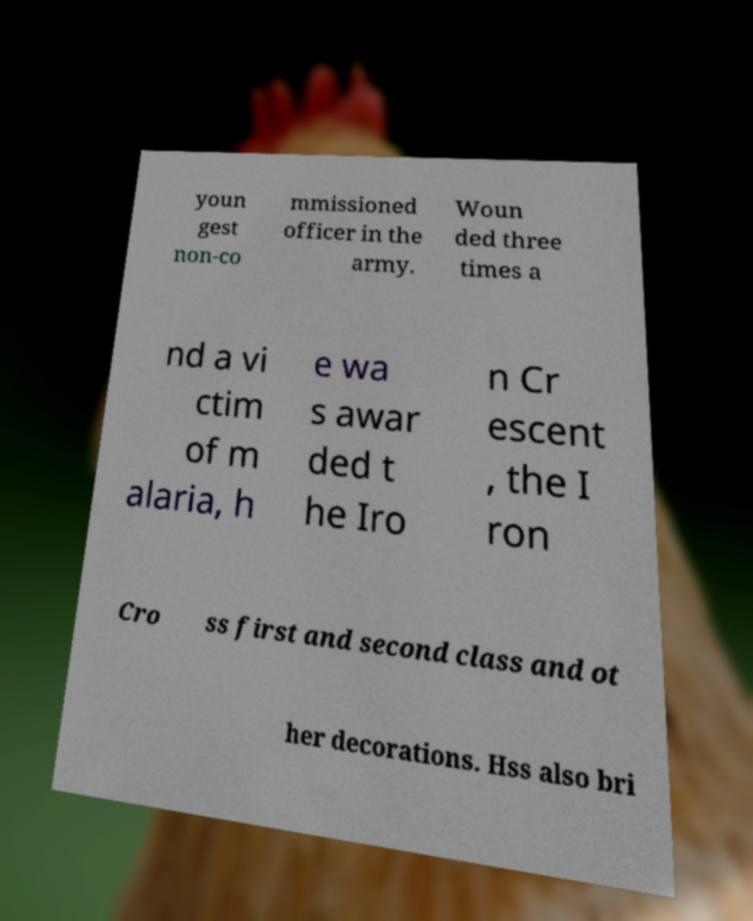Can you accurately transcribe the text from the provided image for me? youn gest non-co mmissioned officer in the army. Woun ded three times a nd a vi ctim of m alaria, h e wa s awar ded t he Iro n Cr escent , the I ron Cro ss first and second class and ot her decorations. Hss also bri 